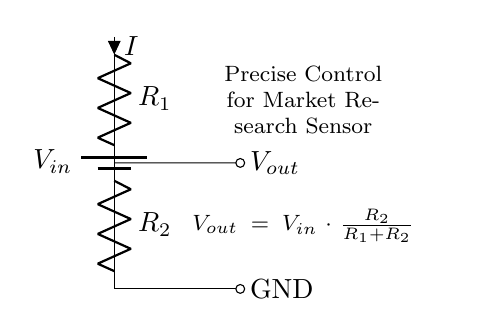What is the input voltage of the circuit? The input voltage, denoted as V_in, is not specified numerically in the diagram, but it's the voltage applied across the first resistor.
Answer: V_in What is the output voltage formula? The output voltage is computed using the formula V_out = V_in * R_2 / (R_1 + R_2), which represents the division of voltage across the resistors.
Answer: V_out = V_in * R_2 / (R_1 + R_2) How many resistors are in the circuit? There are two resistors labeled as R_1 and R_2 in the circuit diagram.
Answer: 2 What is the purpose of this circuit? The purpose is to provide precise control of the sensor output voltage for data collection in market research applications, allowing for specific voltage levels.
Answer: Precise control for sensor output What is the relationship between input and output voltage? The output voltage is a fraction of the input voltage, specifically determined by the ratio of the two resistors, indicating that it scales down the input voltage.
Answer: Scaled down What is the current direction in the circuit? The direction of current flow (I) is indicated as flowing downward through R_1 and then through R_2 to ground, which is a typical behavior in series resistor circuits.
Answer: Downward 